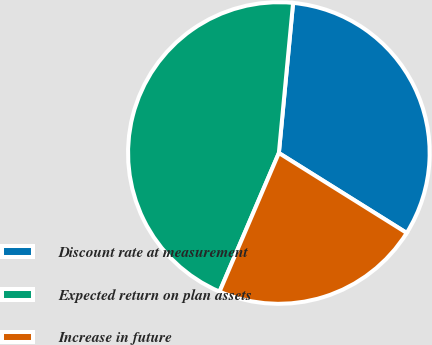Convert chart. <chart><loc_0><loc_0><loc_500><loc_500><pie_chart><fcel>Discount rate at measurement<fcel>Expected return on plan assets<fcel>Increase in future<nl><fcel>32.39%<fcel>45.07%<fcel>22.54%<nl></chart> 